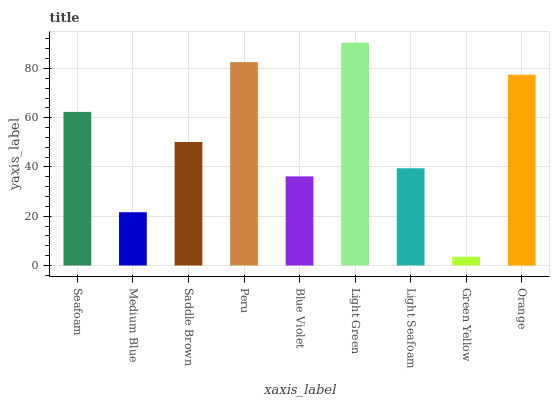Is Green Yellow the minimum?
Answer yes or no. Yes. Is Light Green the maximum?
Answer yes or no. Yes. Is Medium Blue the minimum?
Answer yes or no. No. Is Medium Blue the maximum?
Answer yes or no. No. Is Seafoam greater than Medium Blue?
Answer yes or no. Yes. Is Medium Blue less than Seafoam?
Answer yes or no. Yes. Is Medium Blue greater than Seafoam?
Answer yes or no. No. Is Seafoam less than Medium Blue?
Answer yes or no. No. Is Saddle Brown the high median?
Answer yes or no. Yes. Is Saddle Brown the low median?
Answer yes or no. Yes. Is Medium Blue the high median?
Answer yes or no. No. Is Seafoam the low median?
Answer yes or no. No. 